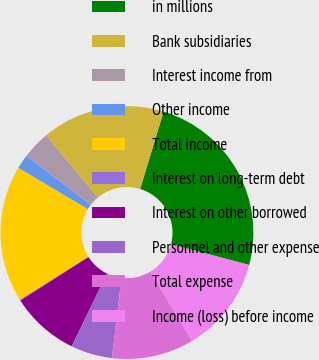Convert chart to OTSL. <chart><loc_0><loc_0><loc_500><loc_500><pie_chart><fcel>in millions<fcel>Bank subsidiaries<fcel>Interest income from<fcel>Other income<fcel>Total income<fcel>Interest on long-term debt<fcel>Interest on other borrowed<fcel>Personnel and other expense<fcel>Total expense<fcel>Income (loss) before income<nl><fcel>24.44%<fcel>15.74%<fcel>3.57%<fcel>1.83%<fcel>17.48%<fcel>0.09%<fcel>8.78%<fcel>5.3%<fcel>10.52%<fcel>12.26%<nl></chart> 